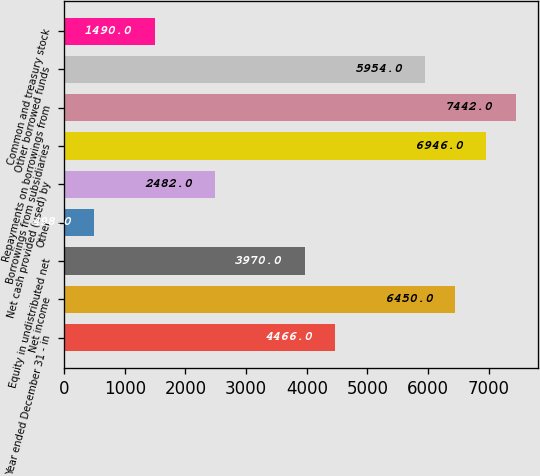Convert chart. <chart><loc_0><loc_0><loc_500><loc_500><bar_chart><fcel>Year ended December 31 - in<fcel>Net income<fcel>Equity in undistributed net<fcel>Other<fcel>Net cash provided (used) by<fcel>Borrowings from subsidiaries<fcel>Repayments on borrowings from<fcel>Other borrowed funds<fcel>Common and treasury stock<nl><fcel>4466<fcel>6450<fcel>3970<fcel>498<fcel>2482<fcel>6946<fcel>7442<fcel>5954<fcel>1490<nl></chart> 